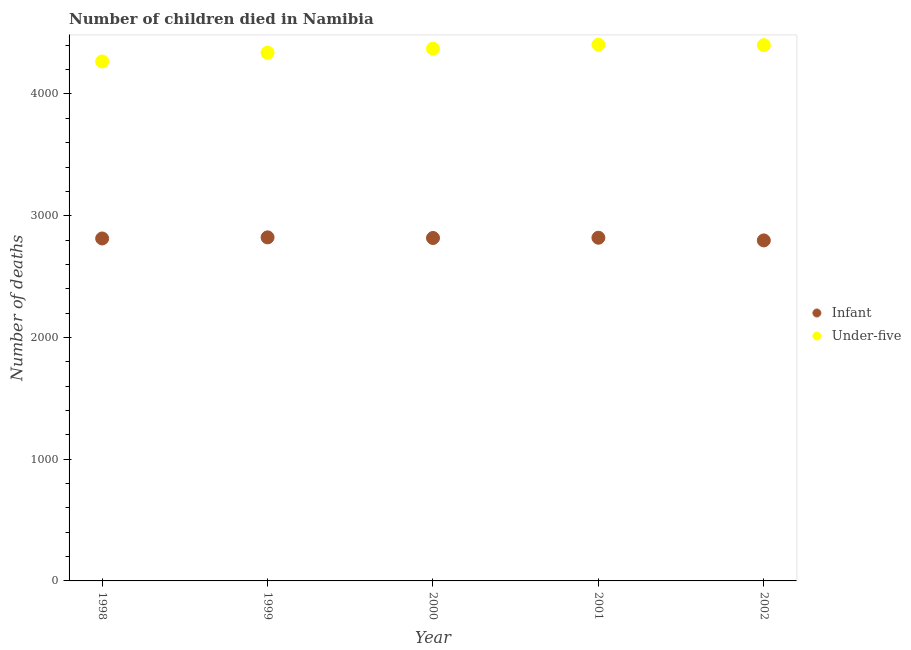How many different coloured dotlines are there?
Ensure brevity in your answer.  2. Is the number of dotlines equal to the number of legend labels?
Your response must be concise. Yes. What is the number of infant deaths in 2000?
Make the answer very short. 2817. Across all years, what is the maximum number of under-five deaths?
Make the answer very short. 4405. Across all years, what is the minimum number of infant deaths?
Ensure brevity in your answer.  2797. In which year was the number of infant deaths maximum?
Your response must be concise. 1999. In which year was the number of infant deaths minimum?
Provide a short and direct response. 2002. What is the total number of infant deaths in the graph?
Keep it short and to the point. 1.41e+04. What is the difference between the number of under-five deaths in 1998 and that in 1999?
Your response must be concise. -72. What is the difference between the number of under-five deaths in 2001 and the number of infant deaths in 2002?
Make the answer very short. 1608. What is the average number of infant deaths per year?
Your response must be concise. 2813.6. In the year 2002, what is the difference between the number of infant deaths and number of under-five deaths?
Your answer should be very brief. -1604. What is the ratio of the number of under-five deaths in 1998 to that in 2001?
Ensure brevity in your answer.  0.97. Is the difference between the number of infant deaths in 1998 and 1999 greater than the difference between the number of under-five deaths in 1998 and 1999?
Keep it short and to the point. Yes. What is the difference between the highest and the second highest number of infant deaths?
Your response must be concise. 3. What is the difference between the highest and the lowest number of under-five deaths?
Your answer should be compact. 138. In how many years, is the number of infant deaths greater than the average number of infant deaths taken over all years?
Offer a very short reply. 3. Is the sum of the number of under-five deaths in 1999 and 2000 greater than the maximum number of infant deaths across all years?
Offer a very short reply. Yes. Does the number of under-five deaths monotonically increase over the years?
Your answer should be compact. No. Is the number of infant deaths strictly less than the number of under-five deaths over the years?
Your response must be concise. Yes. How many dotlines are there?
Give a very brief answer. 2. How many years are there in the graph?
Offer a very short reply. 5. What is the difference between two consecutive major ticks on the Y-axis?
Provide a succinct answer. 1000. Are the values on the major ticks of Y-axis written in scientific E-notation?
Provide a succinct answer. No. Does the graph contain grids?
Make the answer very short. No. What is the title of the graph?
Make the answer very short. Number of children died in Namibia. What is the label or title of the X-axis?
Ensure brevity in your answer.  Year. What is the label or title of the Y-axis?
Provide a succinct answer. Number of deaths. What is the Number of deaths in Infant in 1998?
Offer a very short reply. 2813. What is the Number of deaths in Under-five in 1998?
Keep it short and to the point. 4267. What is the Number of deaths in Infant in 1999?
Ensure brevity in your answer.  2822. What is the Number of deaths of Under-five in 1999?
Your answer should be very brief. 4339. What is the Number of deaths of Infant in 2000?
Provide a short and direct response. 2817. What is the Number of deaths in Under-five in 2000?
Ensure brevity in your answer.  4372. What is the Number of deaths of Infant in 2001?
Offer a very short reply. 2819. What is the Number of deaths in Under-five in 2001?
Provide a succinct answer. 4405. What is the Number of deaths of Infant in 2002?
Make the answer very short. 2797. What is the Number of deaths in Under-five in 2002?
Offer a very short reply. 4401. Across all years, what is the maximum Number of deaths of Infant?
Give a very brief answer. 2822. Across all years, what is the maximum Number of deaths of Under-five?
Make the answer very short. 4405. Across all years, what is the minimum Number of deaths of Infant?
Ensure brevity in your answer.  2797. Across all years, what is the minimum Number of deaths in Under-five?
Offer a very short reply. 4267. What is the total Number of deaths in Infant in the graph?
Offer a terse response. 1.41e+04. What is the total Number of deaths in Under-five in the graph?
Offer a terse response. 2.18e+04. What is the difference between the Number of deaths in Infant in 1998 and that in 1999?
Make the answer very short. -9. What is the difference between the Number of deaths in Under-five in 1998 and that in 1999?
Provide a short and direct response. -72. What is the difference between the Number of deaths of Infant in 1998 and that in 2000?
Give a very brief answer. -4. What is the difference between the Number of deaths of Under-five in 1998 and that in 2000?
Ensure brevity in your answer.  -105. What is the difference between the Number of deaths in Infant in 1998 and that in 2001?
Make the answer very short. -6. What is the difference between the Number of deaths in Under-five in 1998 and that in 2001?
Ensure brevity in your answer.  -138. What is the difference between the Number of deaths of Under-five in 1998 and that in 2002?
Offer a terse response. -134. What is the difference between the Number of deaths in Infant in 1999 and that in 2000?
Your response must be concise. 5. What is the difference between the Number of deaths in Under-five in 1999 and that in 2000?
Your response must be concise. -33. What is the difference between the Number of deaths in Infant in 1999 and that in 2001?
Ensure brevity in your answer.  3. What is the difference between the Number of deaths in Under-five in 1999 and that in 2001?
Keep it short and to the point. -66. What is the difference between the Number of deaths in Under-five in 1999 and that in 2002?
Make the answer very short. -62. What is the difference between the Number of deaths in Under-five in 2000 and that in 2001?
Your answer should be very brief. -33. What is the difference between the Number of deaths of Infant in 2000 and that in 2002?
Your answer should be compact. 20. What is the difference between the Number of deaths in Under-five in 2000 and that in 2002?
Provide a short and direct response. -29. What is the difference between the Number of deaths in Infant in 1998 and the Number of deaths in Under-five in 1999?
Keep it short and to the point. -1526. What is the difference between the Number of deaths of Infant in 1998 and the Number of deaths of Under-five in 2000?
Your answer should be compact. -1559. What is the difference between the Number of deaths in Infant in 1998 and the Number of deaths in Under-five in 2001?
Your answer should be very brief. -1592. What is the difference between the Number of deaths of Infant in 1998 and the Number of deaths of Under-five in 2002?
Your answer should be very brief. -1588. What is the difference between the Number of deaths in Infant in 1999 and the Number of deaths in Under-five in 2000?
Offer a very short reply. -1550. What is the difference between the Number of deaths in Infant in 1999 and the Number of deaths in Under-five in 2001?
Your answer should be very brief. -1583. What is the difference between the Number of deaths of Infant in 1999 and the Number of deaths of Under-five in 2002?
Your answer should be compact. -1579. What is the difference between the Number of deaths of Infant in 2000 and the Number of deaths of Under-five in 2001?
Offer a very short reply. -1588. What is the difference between the Number of deaths in Infant in 2000 and the Number of deaths in Under-five in 2002?
Keep it short and to the point. -1584. What is the difference between the Number of deaths of Infant in 2001 and the Number of deaths of Under-five in 2002?
Ensure brevity in your answer.  -1582. What is the average Number of deaths of Infant per year?
Offer a very short reply. 2813.6. What is the average Number of deaths in Under-five per year?
Provide a succinct answer. 4356.8. In the year 1998, what is the difference between the Number of deaths in Infant and Number of deaths in Under-five?
Provide a short and direct response. -1454. In the year 1999, what is the difference between the Number of deaths of Infant and Number of deaths of Under-five?
Your answer should be very brief. -1517. In the year 2000, what is the difference between the Number of deaths in Infant and Number of deaths in Under-five?
Make the answer very short. -1555. In the year 2001, what is the difference between the Number of deaths in Infant and Number of deaths in Under-five?
Your answer should be very brief. -1586. In the year 2002, what is the difference between the Number of deaths of Infant and Number of deaths of Under-five?
Ensure brevity in your answer.  -1604. What is the ratio of the Number of deaths of Under-five in 1998 to that in 1999?
Offer a very short reply. 0.98. What is the ratio of the Number of deaths of Infant in 1998 to that in 2001?
Keep it short and to the point. 1. What is the ratio of the Number of deaths in Under-five in 1998 to that in 2001?
Give a very brief answer. 0.97. What is the ratio of the Number of deaths of Under-five in 1998 to that in 2002?
Give a very brief answer. 0.97. What is the ratio of the Number of deaths in Infant in 1999 to that in 2000?
Offer a very short reply. 1. What is the ratio of the Number of deaths in Under-five in 1999 to that in 2000?
Your response must be concise. 0.99. What is the ratio of the Number of deaths of Under-five in 1999 to that in 2001?
Offer a very short reply. 0.98. What is the ratio of the Number of deaths in Infant in 1999 to that in 2002?
Keep it short and to the point. 1.01. What is the ratio of the Number of deaths in Under-five in 1999 to that in 2002?
Ensure brevity in your answer.  0.99. What is the ratio of the Number of deaths in Infant in 2001 to that in 2002?
Your response must be concise. 1.01. What is the ratio of the Number of deaths in Under-five in 2001 to that in 2002?
Your response must be concise. 1. What is the difference between the highest and the second highest Number of deaths of Under-five?
Keep it short and to the point. 4. What is the difference between the highest and the lowest Number of deaths in Infant?
Make the answer very short. 25. What is the difference between the highest and the lowest Number of deaths in Under-five?
Provide a short and direct response. 138. 